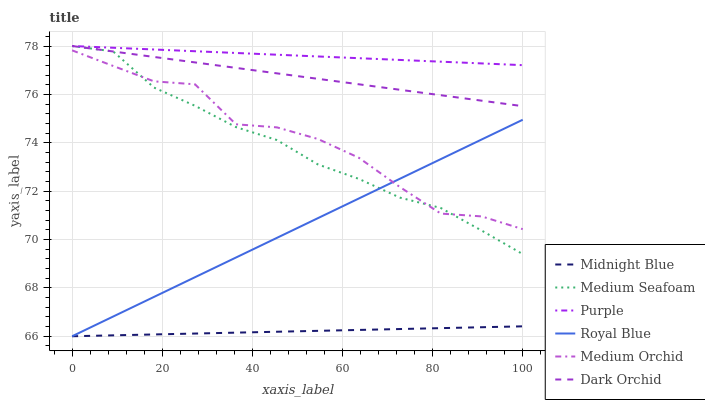Does Midnight Blue have the minimum area under the curve?
Answer yes or no. Yes. Does Purple have the maximum area under the curve?
Answer yes or no. Yes. Does Medium Orchid have the minimum area under the curve?
Answer yes or no. No. Does Medium Orchid have the maximum area under the curve?
Answer yes or no. No. Is Royal Blue the smoothest?
Answer yes or no. Yes. Is Medium Orchid the roughest?
Answer yes or no. Yes. Is Purple the smoothest?
Answer yes or no. No. Is Purple the roughest?
Answer yes or no. No. Does Midnight Blue have the lowest value?
Answer yes or no. Yes. Does Medium Orchid have the lowest value?
Answer yes or no. No. Does Medium Seafoam have the highest value?
Answer yes or no. Yes. Does Medium Orchid have the highest value?
Answer yes or no. No. Is Royal Blue less than Purple?
Answer yes or no. Yes. Is Medium Seafoam greater than Midnight Blue?
Answer yes or no. Yes. Does Royal Blue intersect Midnight Blue?
Answer yes or no. Yes. Is Royal Blue less than Midnight Blue?
Answer yes or no. No. Is Royal Blue greater than Midnight Blue?
Answer yes or no. No. Does Royal Blue intersect Purple?
Answer yes or no. No. 